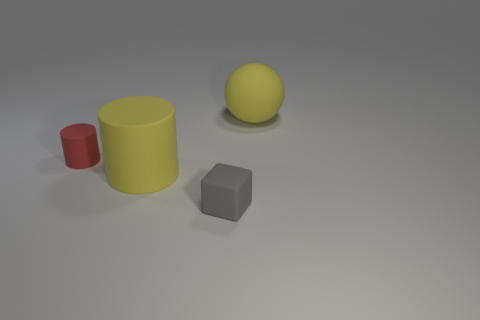How many objects are tiny things behind the rubber block or yellow rubber objects that are on the left side of the big yellow ball?
Ensure brevity in your answer.  2. The thing that is behind the small thing that is behind the small cube is what color?
Keep it short and to the point. Yellow. The cube that is made of the same material as the ball is what color?
Ensure brevity in your answer.  Gray. What number of other cylinders have the same color as the large rubber cylinder?
Provide a succinct answer. 0. How many things are small purple balls or yellow matte balls?
Make the answer very short. 1. What shape is the other rubber thing that is the same size as the red rubber object?
Ensure brevity in your answer.  Cube. What number of things are both to the right of the big yellow cylinder and in front of the small red matte thing?
Ensure brevity in your answer.  1. There is a big yellow object that is on the left side of the large yellow ball; what is it made of?
Your answer should be very brief. Rubber. There is a sphere that is the same material as the red cylinder; what is its size?
Give a very brief answer. Large. Does the yellow matte object to the left of the gray thing have the same size as the yellow object behind the small red rubber thing?
Make the answer very short. Yes. 